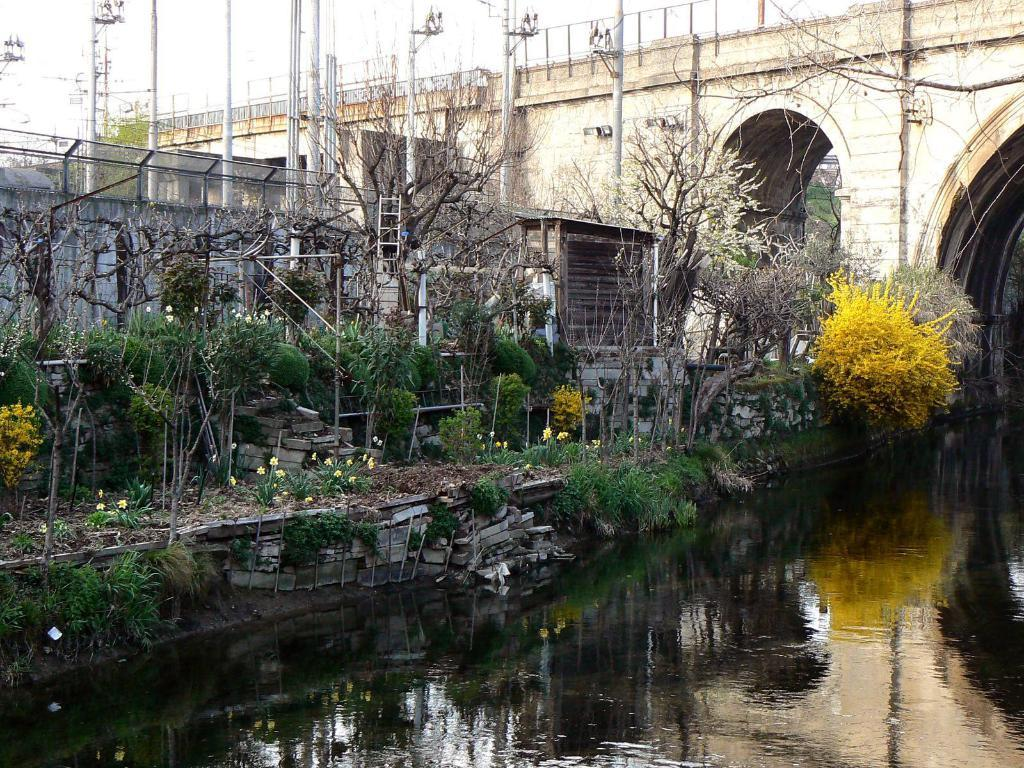What is the primary element in the image? There is water in the image. What type of vegetation can be seen in the image? There are plants with flowers in the image. What type of structure is present in the image? There is a bridge in the image. What are the vertical structures in the image? There are poles in the image. Can you describe the unspecified objects in the image? Unfortunately, the facts provided do not specify the nature of the unspecified objects in the image. What type of sofa can be seen in the image? A: There is no sofa present in the image. What type of division is depicted in the image? The image does not depict any divisions; it features water, plants, a bridge, and poles. 